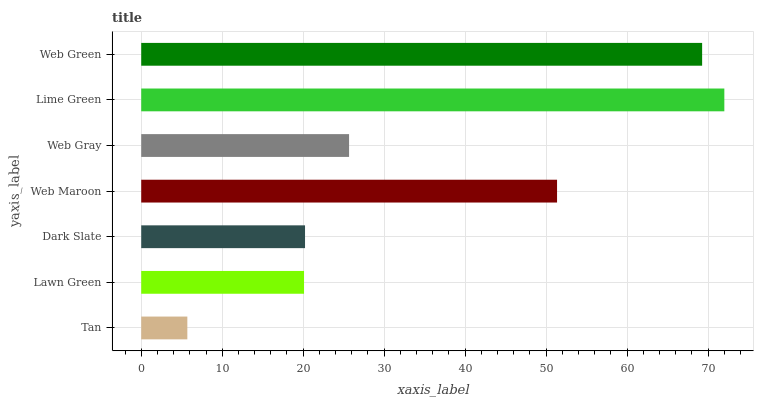Is Tan the minimum?
Answer yes or no. Yes. Is Lime Green the maximum?
Answer yes or no. Yes. Is Lawn Green the minimum?
Answer yes or no. No. Is Lawn Green the maximum?
Answer yes or no. No. Is Lawn Green greater than Tan?
Answer yes or no. Yes. Is Tan less than Lawn Green?
Answer yes or no. Yes. Is Tan greater than Lawn Green?
Answer yes or no. No. Is Lawn Green less than Tan?
Answer yes or no. No. Is Web Gray the high median?
Answer yes or no. Yes. Is Web Gray the low median?
Answer yes or no. Yes. Is Dark Slate the high median?
Answer yes or no. No. Is Lime Green the low median?
Answer yes or no. No. 